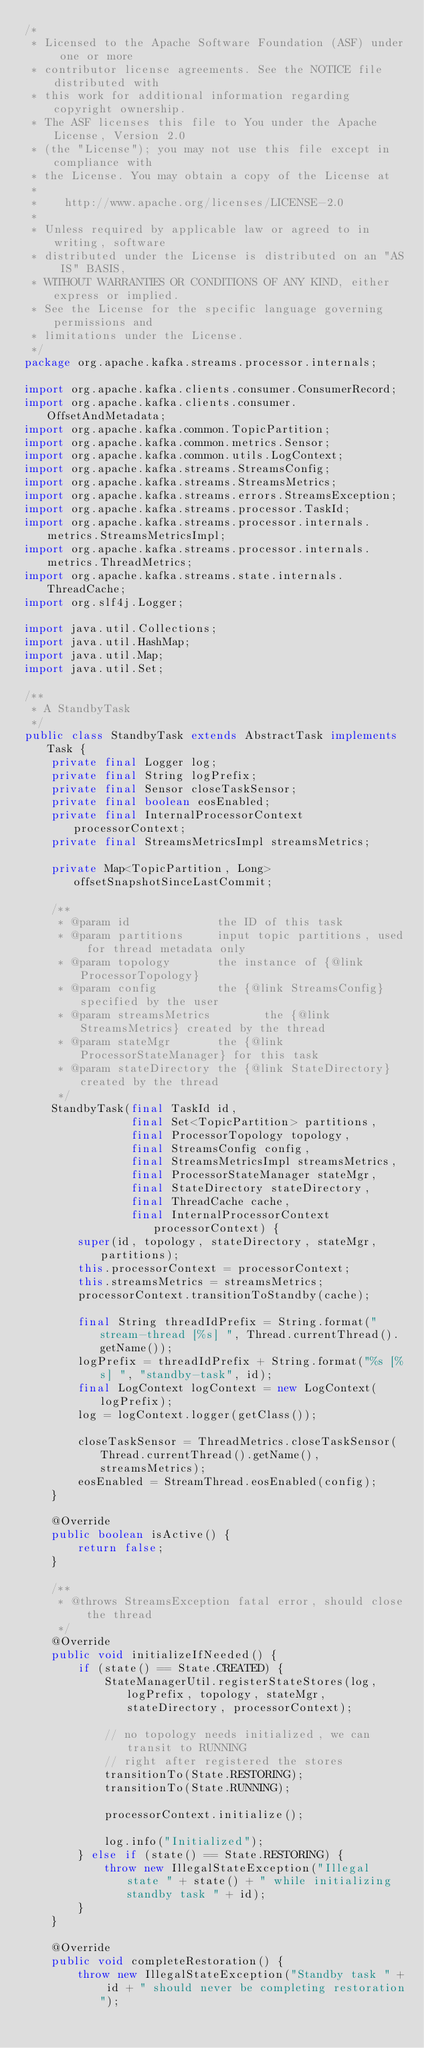<code> <loc_0><loc_0><loc_500><loc_500><_Java_>/*
 * Licensed to the Apache Software Foundation (ASF) under one or more
 * contributor license agreements. See the NOTICE file distributed with
 * this work for additional information regarding copyright ownership.
 * The ASF licenses this file to You under the Apache License, Version 2.0
 * (the "License"); you may not use this file except in compliance with
 * the License. You may obtain a copy of the License at
 *
 *    http://www.apache.org/licenses/LICENSE-2.0
 *
 * Unless required by applicable law or agreed to in writing, software
 * distributed under the License is distributed on an "AS IS" BASIS,
 * WITHOUT WARRANTIES OR CONDITIONS OF ANY KIND, either express or implied.
 * See the License for the specific language governing permissions and
 * limitations under the License.
 */
package org.apache.kafka.streams.processor.internals;

import org.apache.kafka.clients.consumer.ConsumerRecord;
import org.apache.kafka.clients.consumer.OffsetAndMetadata;
import org.apache.kafka.common.TopicPartition;
import org.apache.kafka.common.metrics.Sensor;
import org.apache.kafka.common.utils.LogContext;
import org.apache.kafka.streams.StreamsConfig;
import org.apache.kafka.streams.StreamsMetrics;
import org.apache.kafka.streams.errors.StreamsException;
import org.apache.kafka.streams.processor.TaskId;
import org.apache.kafka.streams.processor.internals.metrics.StreamsMetricsImpl;
import org.apache.kafka.streams.processor.internals.metrics.ThreadMetrics;
import org.apache.kafka.streams.state.internals.ThreadCache;
import org.slf4j.Logger;

import java.util.Collections;
import java.util.HashMap;
import java.util.Map;
import java.util.Set;

/**
 * A StandbyTask
 */
public class StandbyTask extends AbstractTask implements Task {
    private final Logger log;
    private final String logPrefix;
    private final Sensor closeTaskSensor;
    private final boolean eosEnabled;
    private final InternalProcessorContext processorContext;
    private final StreamsMetricsImpl streamsMetrics;

    private Map<TopicPartition, Long> offsetSnapshotSinceLastCommit;

    /**
     * @param id             the ID of this task
     * @param partitions     input topic partitions, used for thread metadata only
     * @param topology       the instance of {@link ProcessorTopology}
     * @param config         the {@link StreamsConfig} specified by the user
     * @param streamsMetrics        the {@link StreamsMetrics} created by the thread
     * @param stateMgr       the {@link ProcessorStateManager} for this task
     * @param stateDirectory the {@link StateDirectory} created by the thread
     */
    StandbyTask(final TaskId id,
                final Set<TopicPartition> partitions,
                final ProcessorTopology topology,
                final StreamsConfig config,
                final StreamsMetricsImpl streamsMetrics,
                final ProcessorStateManager stateMgr,
                final StateDirectory stateDirectory,
                final ThreadCache cache,
                final InternalProcessorContext processorContext) {
        super(id, topology, stateDirectory, stateMgr, partitions);
        this.processorContext = processorContext;
        this.streamsMetrics = streamsMetrics;
        processorContext.transitionToStandby(cache);

        final String threadIdPrefix = String.format("stream-thread [%s] ", Thread.currentThread().getName());
        logPrefix = threadIdPrefix + String.format("%s [%s] ", "standby-task", id);
        final LogContext logContext = new LogContext(logPrefix);
        log = logContext.logger(getClass());

        closeTaskSensor = ThreadMetrics.closeTaskSensor(Thread.currentThread().getName(), streamsMetrics);
        eosEnabled = StreamThread.eosEnabled(config);
    }

    @Override
    public boolean isActive() {
        return false;
    }

    /**
     * @throws StreamsException fatal error, should close the thread
     */
    @Override
    public void initializeIfNeeded() {
        if (state() == State.CREATED) {
            StateManagerUtil.registerStateStores(log, logPrefix, topology, stateMgr, stateDirectory, processorContext);

            // no topology needs initialized, we can transit to RUNNING
            // right after registered the stores
            transitionTo(State.RESTORING);
            transitionTo(State.RUNNING);

            processorContext.initialize();

            log.info("Initialized");
        } else if (state() == State.RESTORING) {
            throw new IllegalStateException("Illegal state " + state() + " while initializing standby task " + id);
        }
    }

    @Override
    public void completeRestoration() {
        throw new IllegalStateException("Standby task " + id + " should never be completing restoration");</code> 